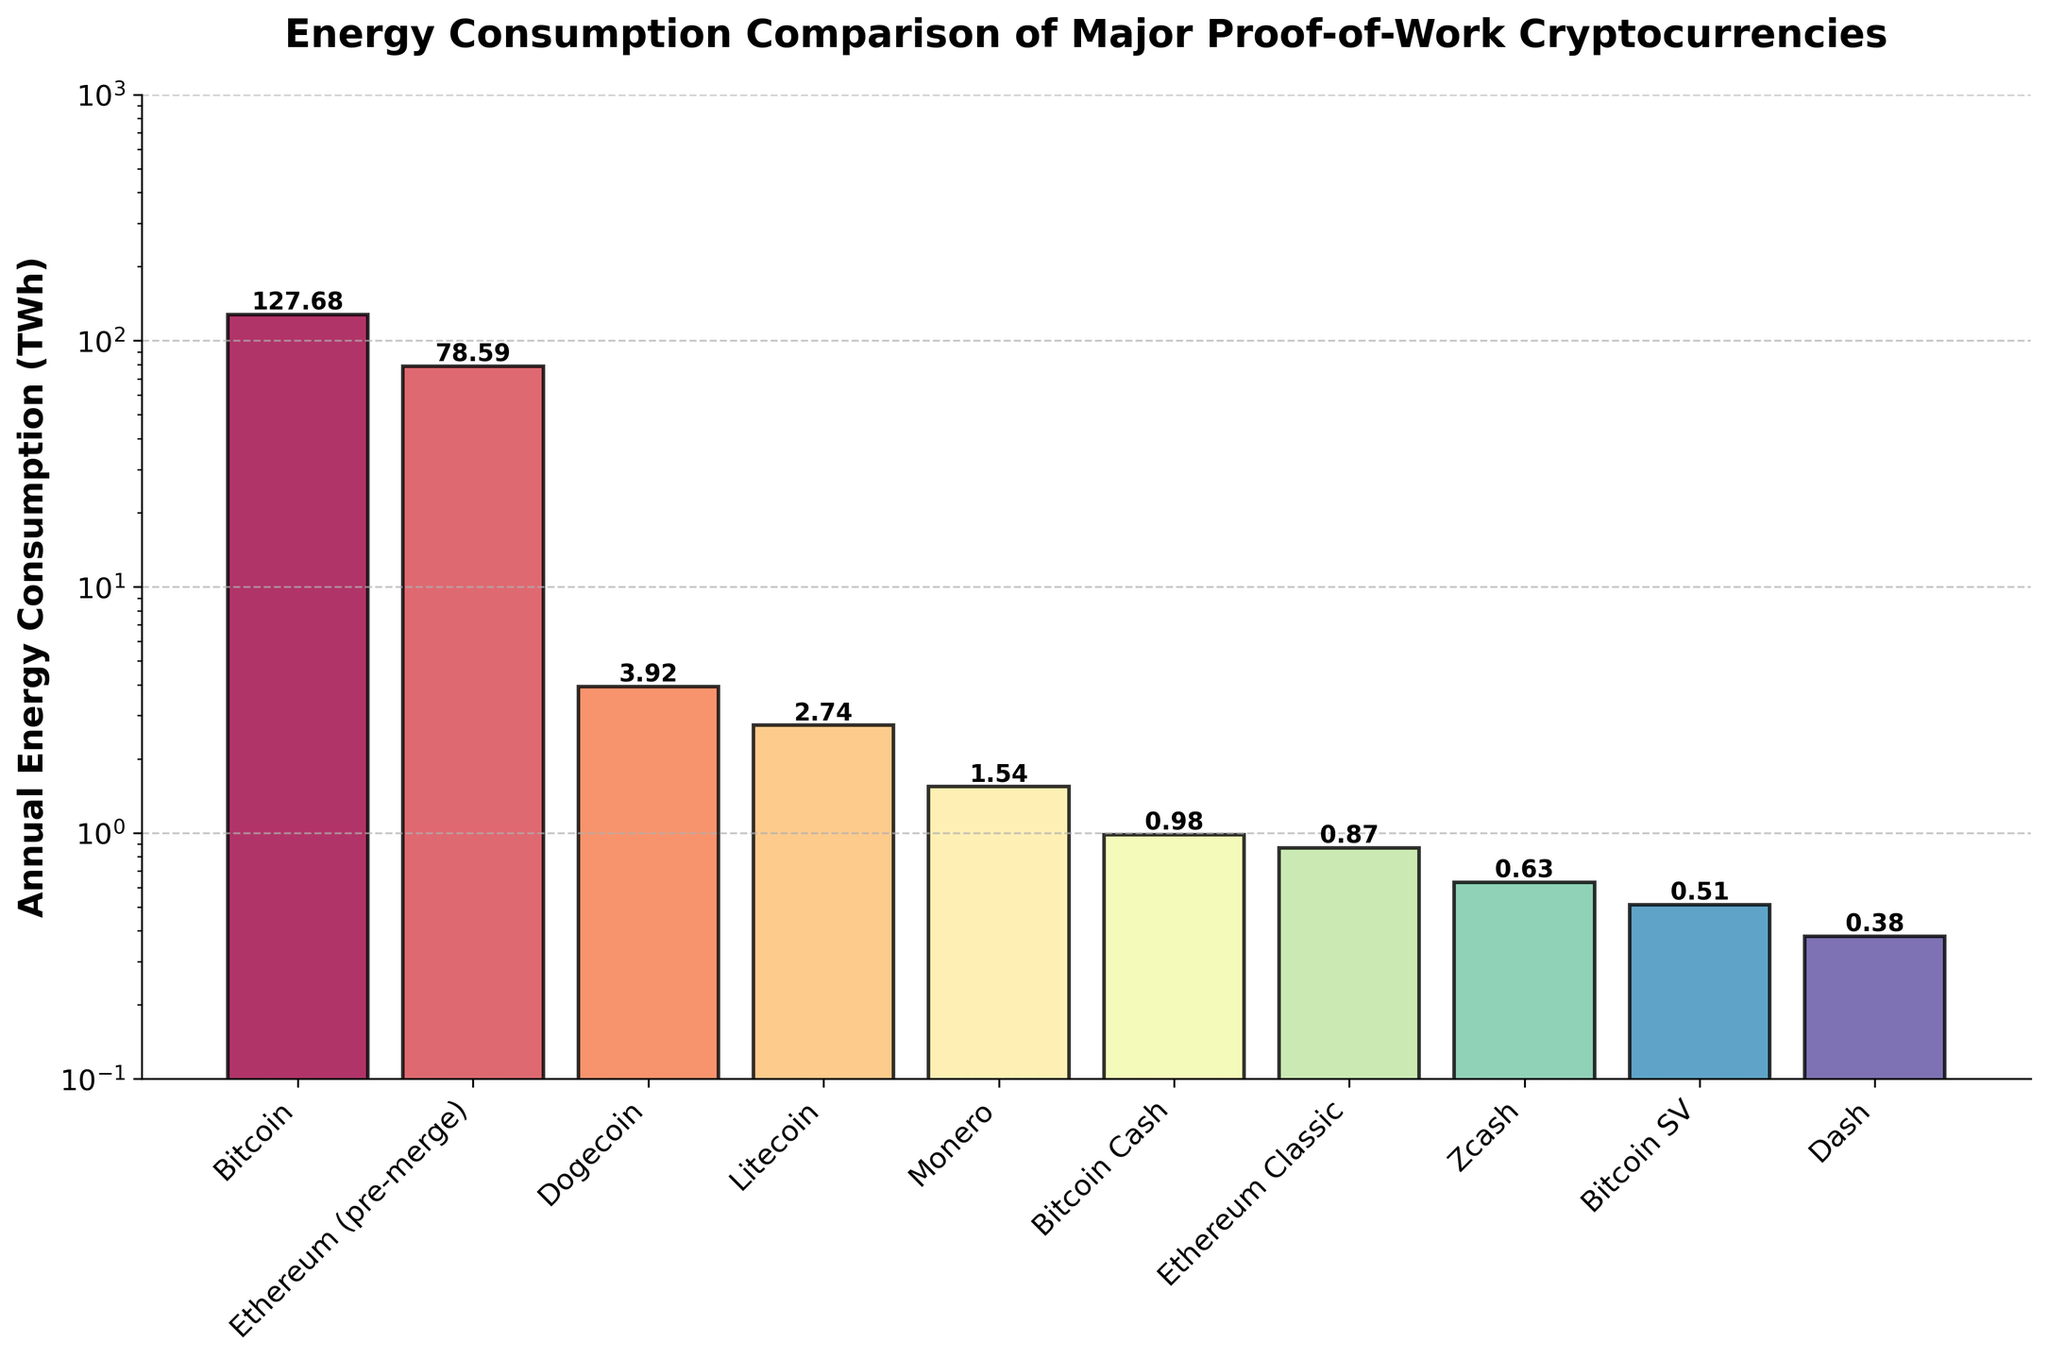What is the cryptocurrency with the highest annual energy consumption? By observing the heights of the bars in the chart, Bitcoin's bar is the highest among all. Hence, Bitcoin has the highest annual energy consumption.
Answer: Bitcoin Which cryptocurrency has a lower annual energy consumption than Dogecoin but higher than Litecoin? By analyzing the height of the bars, Monero's bar is higher than Litecoin's and lower than Dogecoin's.
Answer: Monero How much more energy does Ethereum (pre-merge) consume annually compared to Bitcoin Cash? The height of Ethereum (pre-merge) is represented by 78.59 TWh, and Bitcoin Cash by 0.98 TWh. The difference is 78.59 - 0.98 = 77.61 TWh.
Answer: 77.61 TWh What is the combined annual energy consumption of Dogecoin and Litecoin? The individual annual consumptions are 3.92 TWh for Dogecoin and 2.74 TWh for Litecoin. Combined, it is 3.92 + 2.74 = 6.66 TWh.
Answer: 6.66 TWh Comparatively, which has a higher annual energy consumption, Ethereum Classic or Zcash? By comparing the heights of the bars, Ethereum Classic has a higher annual energy consumption than Zcash.
Answer: Ethereum Classic What does the y-axis scale of the graph represent, and how is it set? The y-axis represents the annual energy consumption in TWh and is set on a logarithmic scale ranging from 0.1 to 1000.
Answer: Annual energy consumption in TWh, logarithmic scale Which cryptocurrency has an annual energy consumption closest to 1 TWh? By checking the height of the bars around the 1 TWh mark, Monero has an annual energy consumption of 1.54 TWh, which is closest to 1 TWh.
Answer: Monero How many cryptocurrencies consume more than 10 TWh annually? By examining the heights of the bars, Bitcoin and Ethereum (pre-merge) are the only cryptocurrencies consuming more than 10 TWh annually.
Answer: 2 What is the color gradient used in the bars of the chart? The bars use a color gradient from a colormap that transitions through various spectral colors.
Answer: Spectral colors 